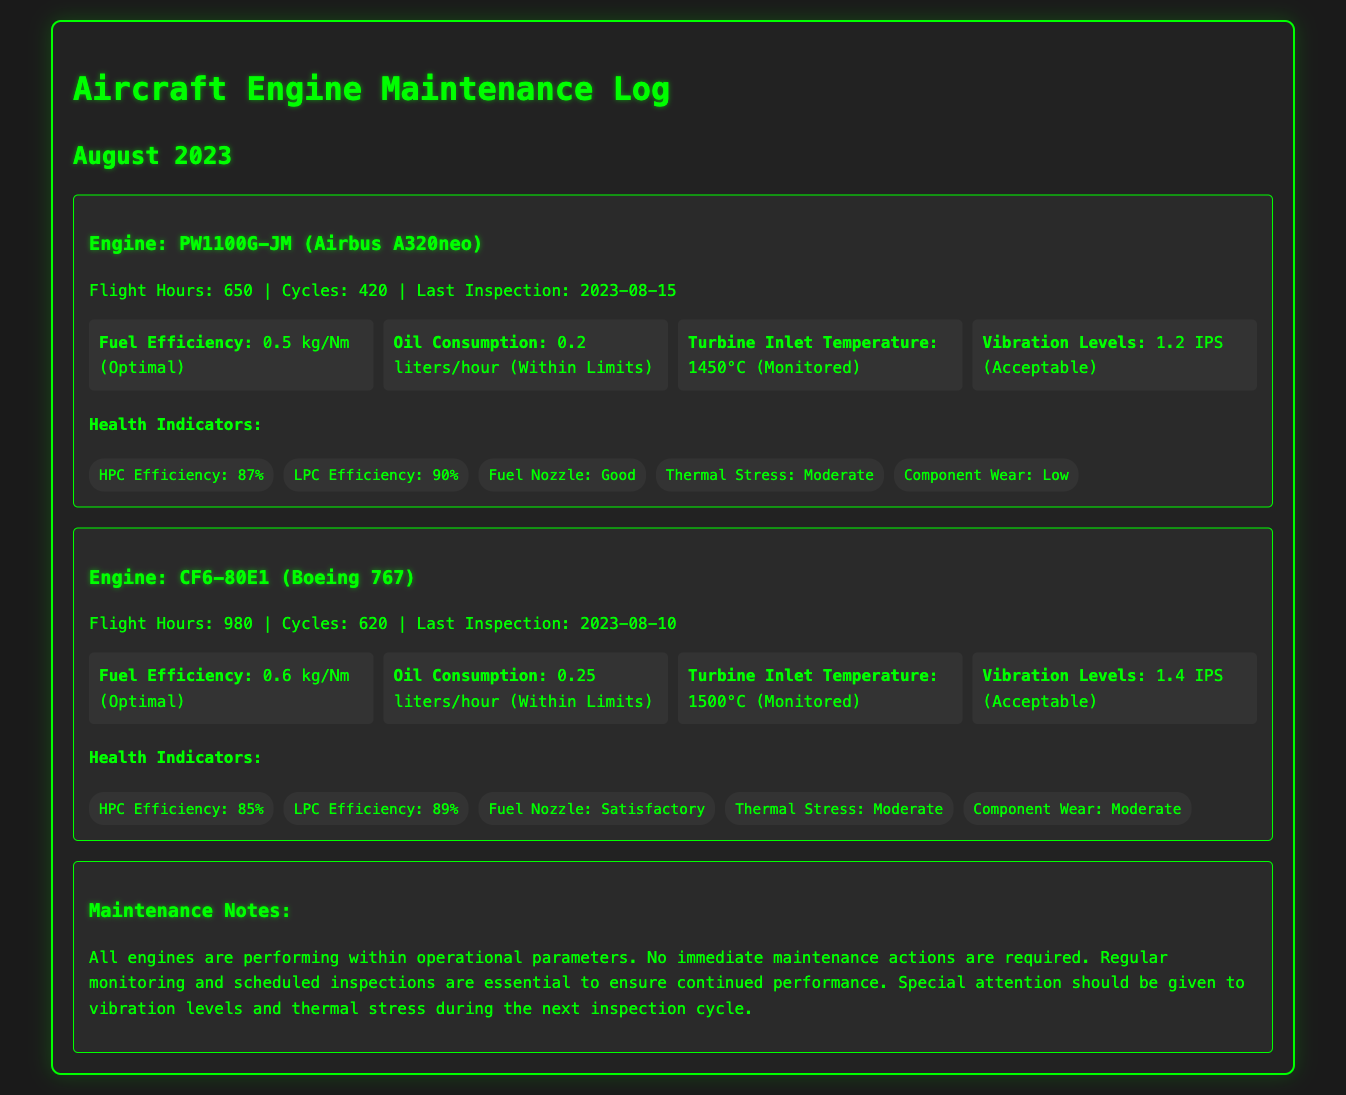what is the total flight hours for the PW1100G-JM engine? The total flight hours for the PW1100G-JM engine is stated directly in the document.
Answer: 650 what is the last inspection date for the CF6-80E1 engine? The last inspection date is noted in the details of each engine in the document.
Answer: 2023-08-10 what is the oil consumption rate of the PW1100G-JM engine? The oil consumption rate can be found in the metrics provided for each engine.
Answer: 0.2 liters/hour what is the HPC efficiency of the CF6-80E1 engine? The HPC efficiency is listed under health indicators for each engine.
Answer: 85% how does the thermal stress of the PW1100G-JM engine compare to that of the CF6-80E1 engine? Comparison requires reasoning over both entries concerning thermal stress.
Answer: Both are Moderate what is the vibration level considered acceptable for the CF6-80E1 engine? The vibration level is specified in the metrics section of the document.
Answer: 1.4 IPS what should be monitored during the next inspection cycle according to the maintenance notes? The maintenance notes highlight the areas that require special attention during inspections.
Answer: Vibration levels and thermal stress what is the fuel efficiency of the CF6-80E1 engine? The fuel efficiency is detailed in the metrics for each engine.
Answer: 0.6 kg/Nm what type of document is represented here? The type of document is indicated in the title and header.
Answer: Maintenance Log 